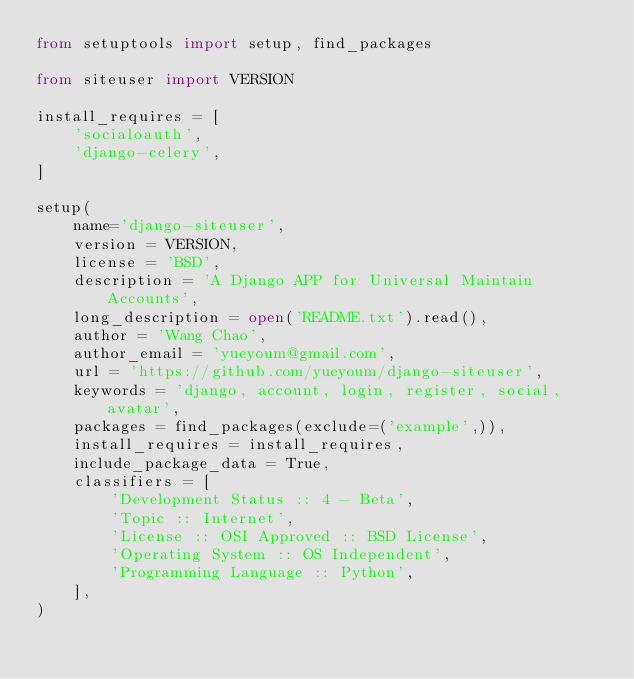<code> <loc_0><loc_0><loc_500><loc_500><_Python_>from setuptools import setup, find_packages

from siteuser import VERSION

install_requires = [
    'socialoauth',
    'django-celery',
]

setup(
    name='django-siteuser',
    version = VERSION,
    license = 'BSD',
    description = 'A Django APP for Universal Maintain Accounts',
    long_description = open('README.txt').read(),
    author = 'Wang Chao',
    author_email = 'yueyoum@gmail.com',
    url = 'https://github.com/yueyoum/django-siteuser',
    keywords = 'django, account, login, register, social, avatar',
    packages = find_packages(exclude=('example',)),
    install_requires = install_requires,
    include_package_data = True,
    classifiers = [
        'Development Status :: 4 - Beta',
        'Topic :: Internet',
        'License :: OSI Approved :: BSD License',
        'Operating System :: OS Independent',
        'Programming Language :: Python',
    ],
)
</code> 